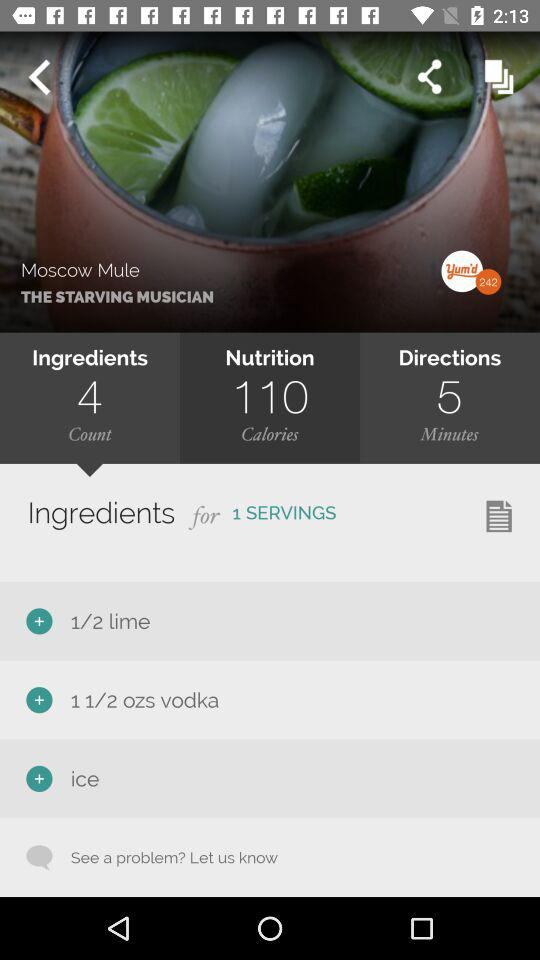How many ingredients do we need to make this dish? You need 4 ingredients to make this dish. 